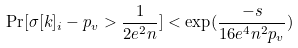<formula> <loc_0><loc_0><loc_500><loc_500>\Pr [ \sigma [ k ] _ { i } - p _ { v } > \frac { 1 } { 2 e ^ { 2 } n } ] < \exp ( \frac { - s } { 1 6 e ^ { 4 } n ^ { 2 } p _ { v } } )</formula> 